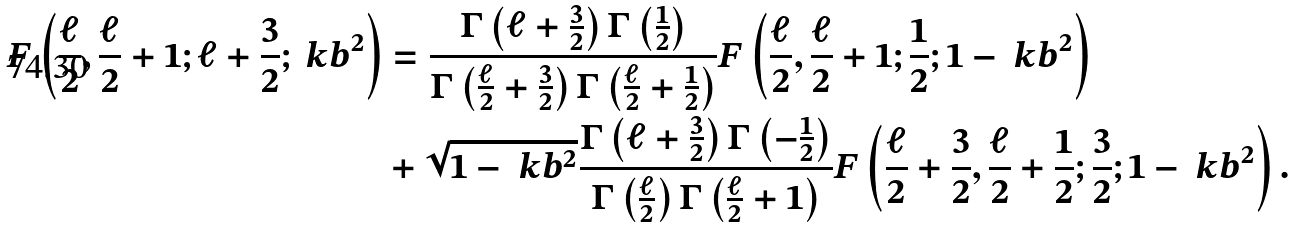<formula> <loc_0><loc_0><loc_500><loc_500>F \left ( \frac { \ell } { 2 } , \frac { \ell } { 2 } + 1 ; \ell + \frac { 3 } { 2 } ; \ k b ^ { 2 } \right ) & = \frac { \Gamma \left ( \ell + \frac { 3 } { 2 } \right ) \Gamma \left ( \frac { 1 } { 2 } \right ) } { \Gamma \left ( \frac { \ell } { 2 } + \frac { 3 } { 2 } \right ) \Gamma \left ( \frac { \ell } { 2 } + \frac { 1 } { 2 } \right ) } F \left ( \frac { \ell } { 2 } , \frac { \ell } { 2 } + 1 ; \frac { 1 } { 2 } ; 1 - \ k b ^ { 2 } \right ) \\ & + \sqrt { 1 - \ k b ^ { 2 } } \frac { \Gamma \left ( \ell + \frac { 3 } { 2 } \right ) \Gamma \left ( - \frac { 1 } { 2 } \right ) } { \Gamma \left ( \frac { \ell } { 2 } \right ) \Gamma \left ( \frac { \ell } { 2 } + 1 \right ) } F \left ( \frac { \ell } { 2 } + \frac { 3 } { 2 } , \frac { \ell } { 2 } + \frac { 1 } { 2 } ; \frac { 3 } { 2 } ; 1 - \ k b ^ { 2 } \right ) .</formula> 